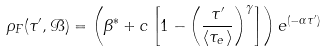Convert formula to latex. <formula><loc_0><loc_0><loc_500><loc_500>\rho _ { F } ( \tau ^ { \prime } , { \mathcal { B } } ) = \left ( \beta ^ { * } + c \left [ 1 - \left ( \frac { \tau ^ { \prime } } { \langle \tau _ { e } \rangle } \right ) ^ { \gamma } \right ] \right ) e ^ { ( - \alpha \tau ^ { \prime } ) }</formula> 